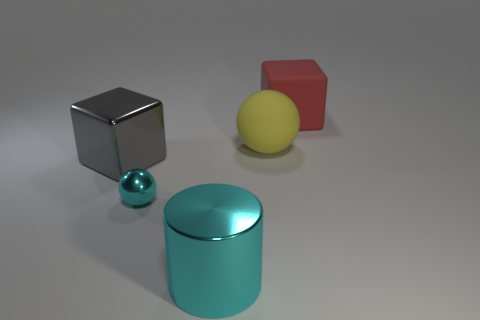The shiny object that is the same color as the tiny ball is what shape?
Give a very brief answer. Cylinder. There is a large thing on the right side of the yellow thing; is it the same shape as the large cyan thing that is in front of the large yellow rubber object?
Give a very brief answer. No. There is a cyan shiny object that is left of the big cyan metal thing; is there a large yellow rubber thing to the left of it?
Give a very brief answer. No. Are any yellow spheres visible?
Your answer should be compact. Yes. How many other matte blocks have the same size as the red matte block?
Offer a terse response. 0. How many objects are both behind the gray object and left of the large red thing?
Offer a terse response. 1. Does the block that is behind the shiny cube have the same size as the big shiny cube?
Offer a very short reply. Yes. Is there a matte object of the same color as the tiny metallic object?
Your answer should be very brief. No. What is the size of the gray cube that is made of the same material as the cyan cylinder?
Your answer should be compact. Large. Is the number of cyan metallic spheres that are behind the small shiny ball greater than the number of big red cubes on the left side of the large red rubber cube?
Your response must be concise. No. 